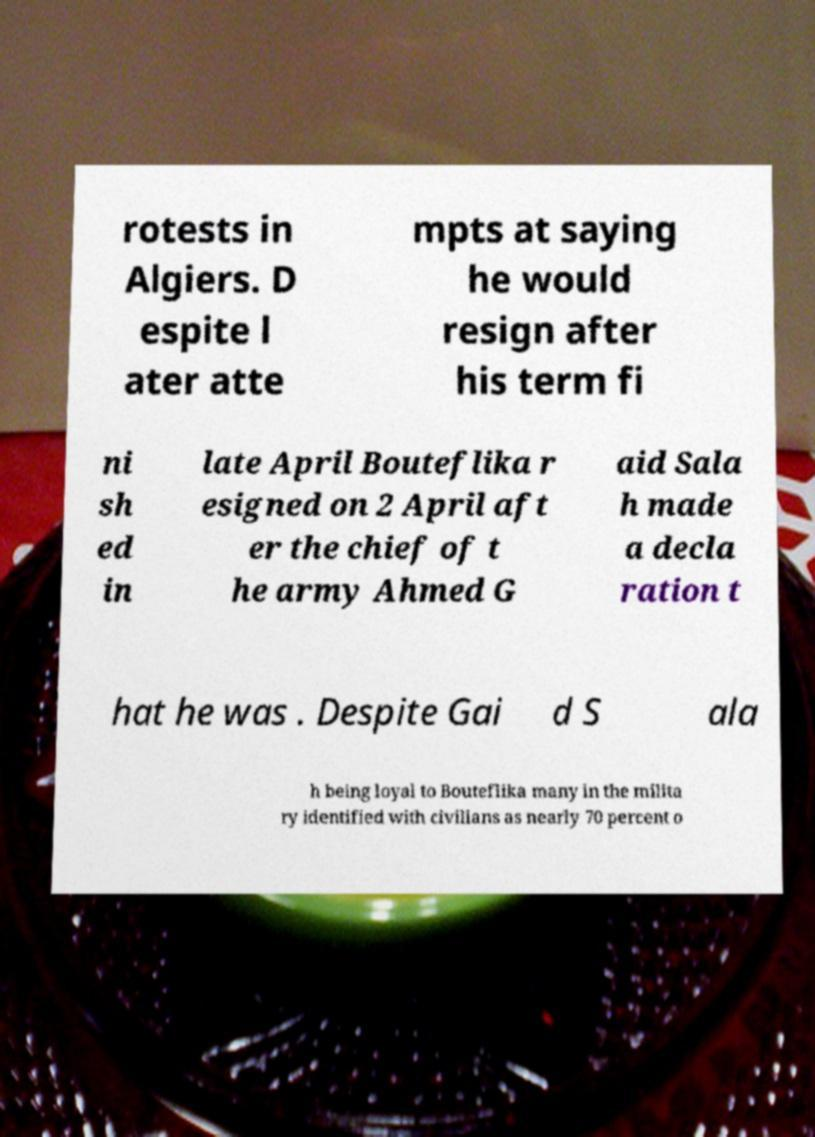Please read and relay the text visible in this image. What does it say? rotests in Algiers. D espite l ater atte mpts at saying he would resign after his term fi ni sh ed in late April Bouteflika r esigned on 2 April aft er the chief of t he army Ahmed G aid Sala h made a decla ration t hat he was . Despite Gai d S ala h being loyal to Bouteflika many in the milita ry identified with civilians as nearly 70 percent o 